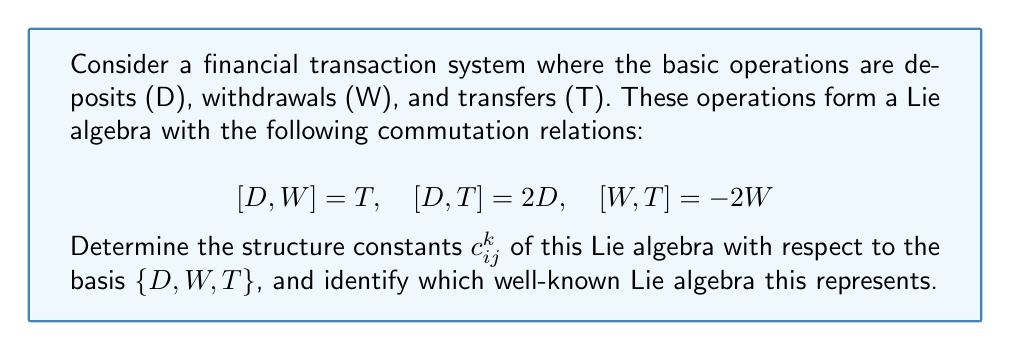Could you help me with this problem? To solve this problem, we need to follow these steps:

1) Recall that for a Lie algebra with basis elements $X_i$, the structure constants $c_{ij}^k$ are defined by the relation:

   $$[X_i, X_j] = \sum_k c_{ij}^k X_k$$

2) From the given commutation relations, we can identify:

   $$[D,W] = T \implies c_{12}^3 = 1, c_{21}^3 = -1$$
   $$[D,T] = 2D \implies c_{13}^1 = 2, c_{31}^1 = -2$$
   $$[W,T] = -2W \implies c_{23}^2 = -2, c_{32}^2 = 2$$

3) All other structure constants are zero.

4) We can represent these structure constants in a 3x3x3 array:

   $$c_{ij}^k = \begin{bmatrix}
   0 & 1 & 2 \\
   -1 & 0 & 0 \\
   -2 & 0 & 0
   \end{bmatrix}, \quad
   \begin{bmatrix}
   0 & 0 & 0 \\
   0 & 0 & -2 \\
   0 & 2 & 0
   \end{bmatrix}, \quad
   \begin{bmatrix}
   0 & 1 & 0 \\
   -1 & 0 & 0 \\
   0 & 0 & 0
   \end{bmatrix}$$

5) To identify this Lie algebra, we note that these commutation relations are characteristic of the special linear Lie algebra $\mathfrak{sl}(2,\mathbb{R})$, which is the Lie algebra of 2x2 matrices with trace zero.

6) We can make this identification explicit by relating our basis elements to the standard basis of $\mathfrak{sl}(2,\mathbb{R})$:

   $$D = \frac{1}{2}\begin{pmatrix} 1 & 0 \\ 0 & -1 \end{pmatrix}, \quad
   W = \begin{pmatrix} 0 & 0 \\ 1 & 0 \end{pmatrix}, \quad
   T = \begin{pmatrix} 0 & 1 \\ 0 & 0 \end{pmatrix}$$

   It's straightforward to verify that these matrices satisfy the given commutation relations.
Answer: The structure constants $c_{ij}^k$ of the Lie algebra are:

$$c_{12}^3 = 1, c_{21}^3 = -1, c_{13}^1 = 2, c_{31}^1 = -2, c_{23}^2 = -2, c_{32}^2 = 2$$

with all other $c_{ij}^k = 0$.

This Lie algebra is isomorphic to $\mathfrak{sl}(2,\mathbb{R})$, the special linear Lie algebra of 2x2 real matrices with trace zero. 